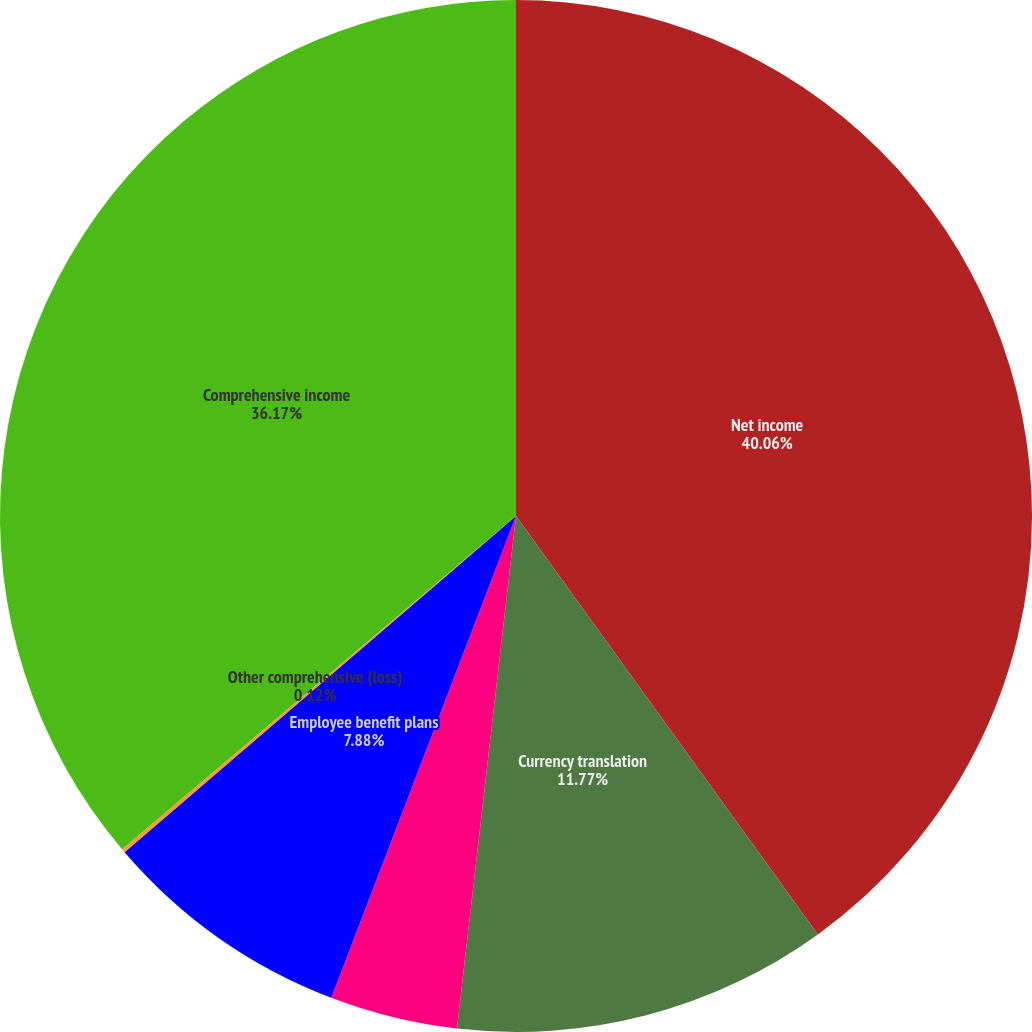<chart> <loc_0><loc_0><loc_500><loc_500><pie_chart><fcel>Net income<fcel>Currency translation<fcel>Net change in unrecognized<fcel>Employee benefit plans<fcel>Other comprehensive (loss)<fcel>Comprehensive income<nl><fcel>40.05%<fcel>11.77%<fcel>4.0%<fcel>7.88%<fcel>0.12%<fcel>36.17%<nl></chart> 